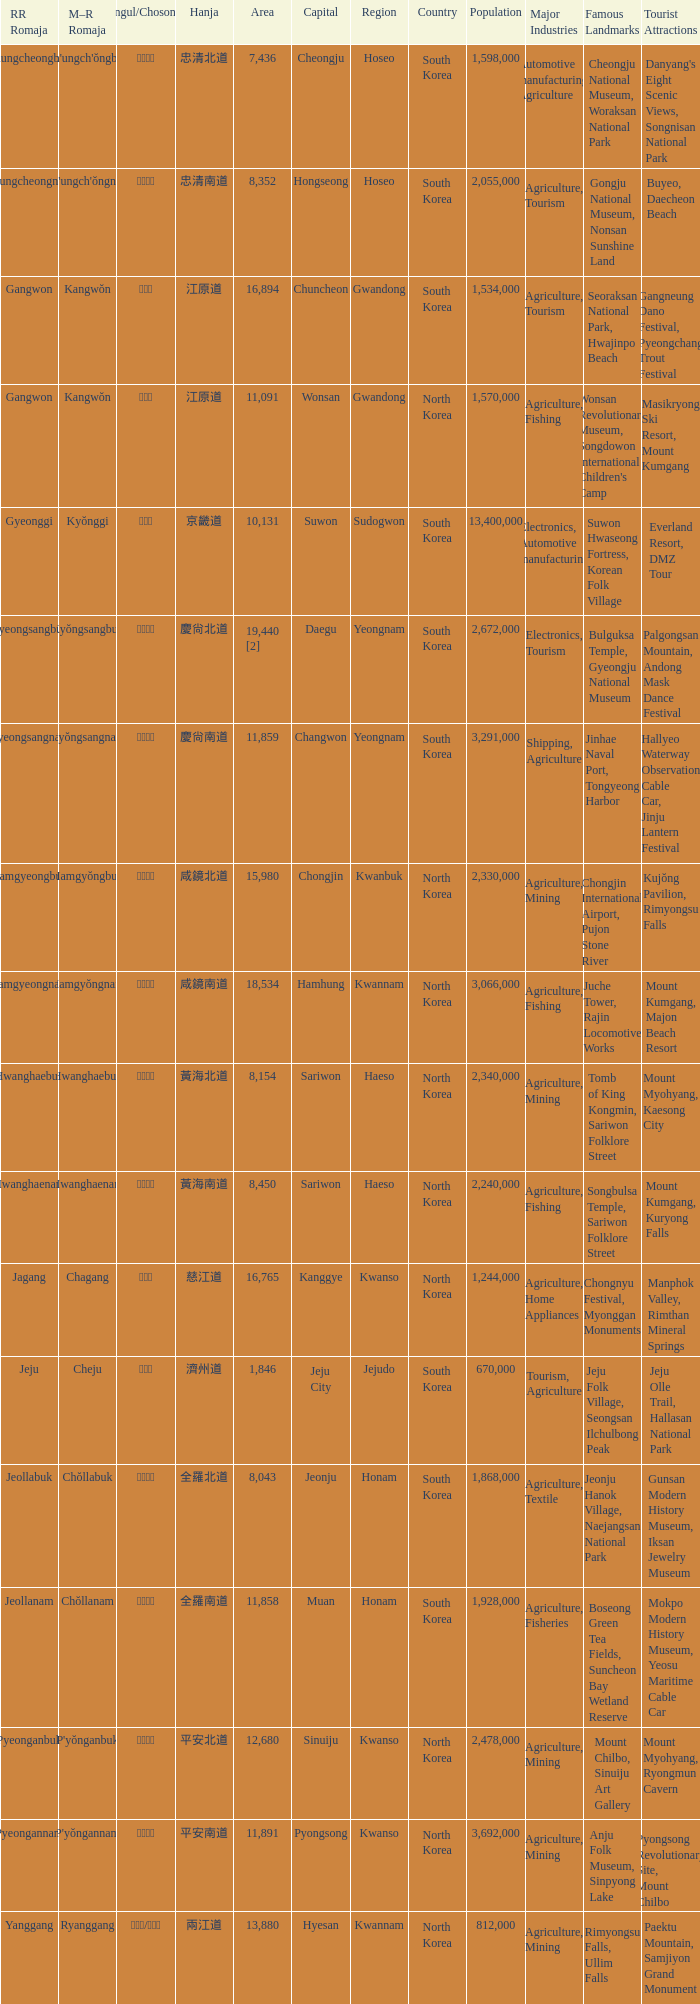Which capital has a Hangul of 경상남도? Changwon. 